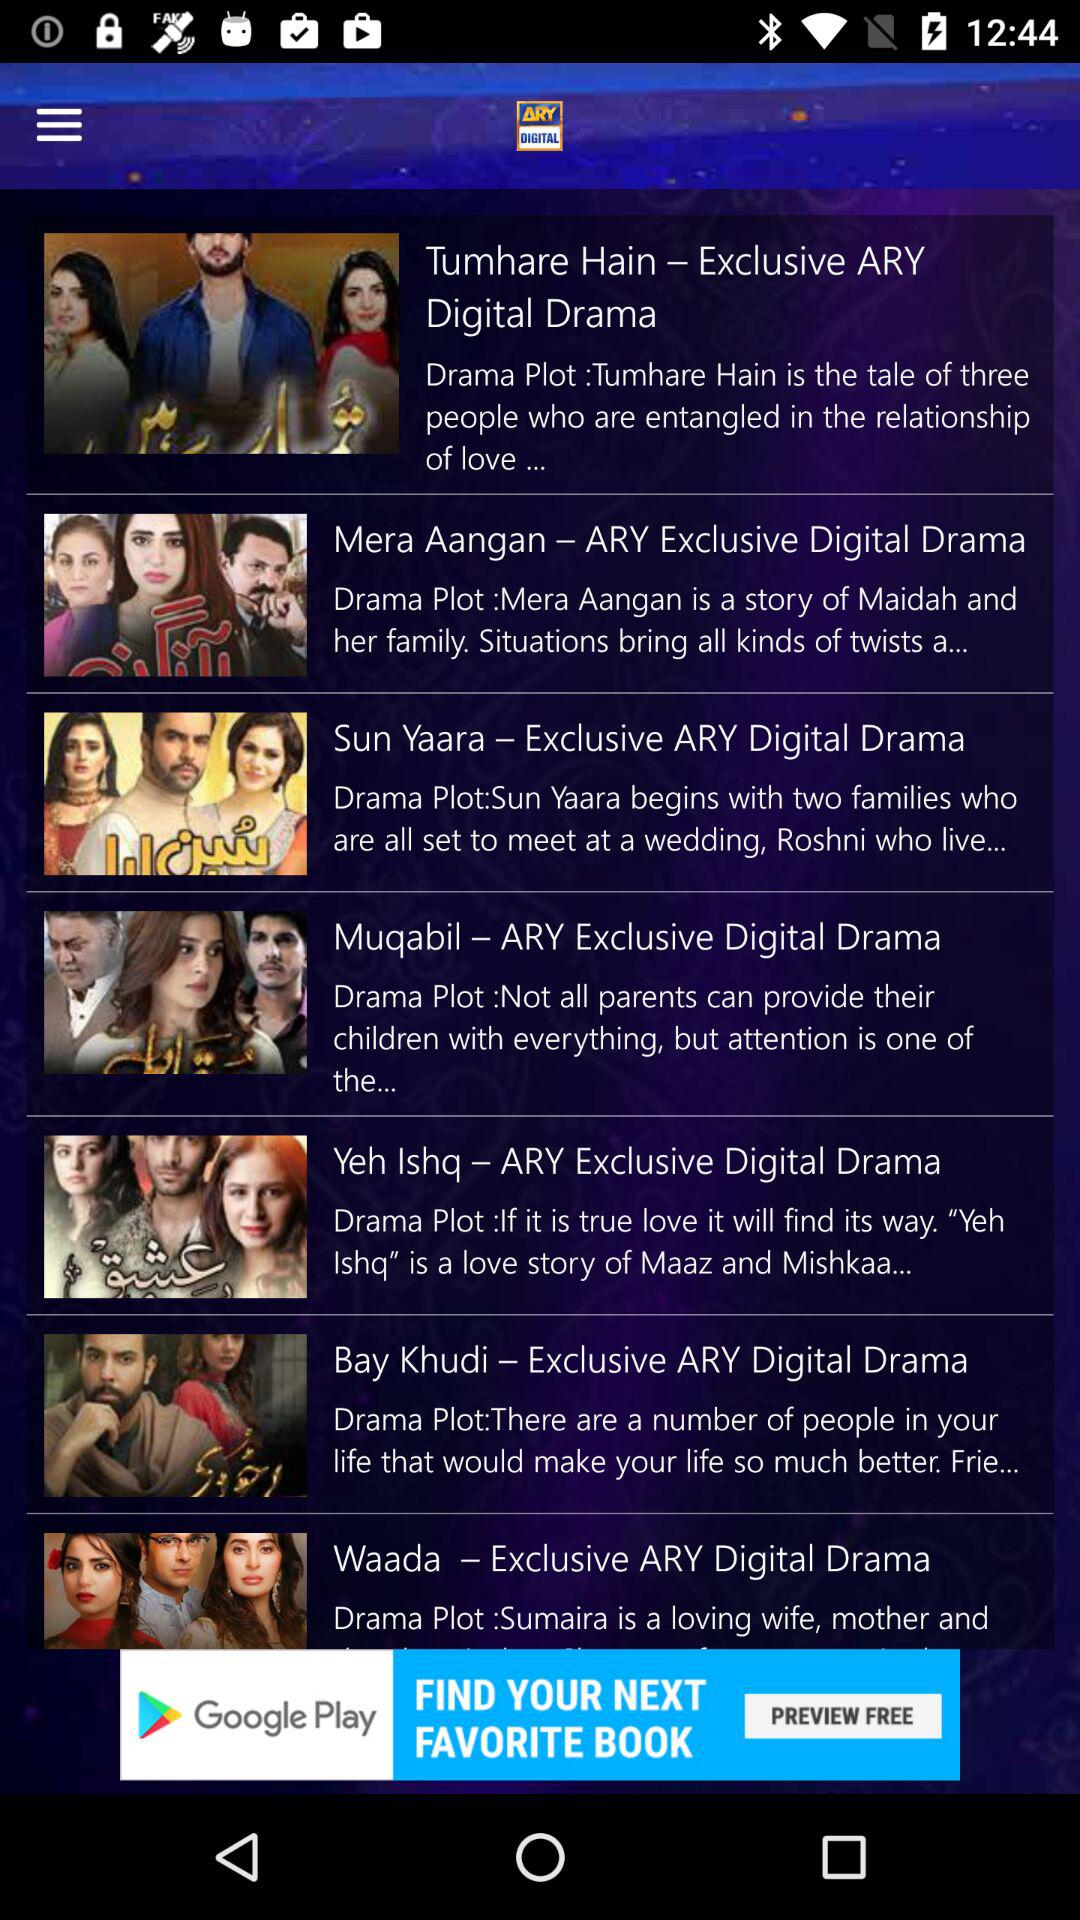What is the application name? The application name is "ARY DIGITAL". 